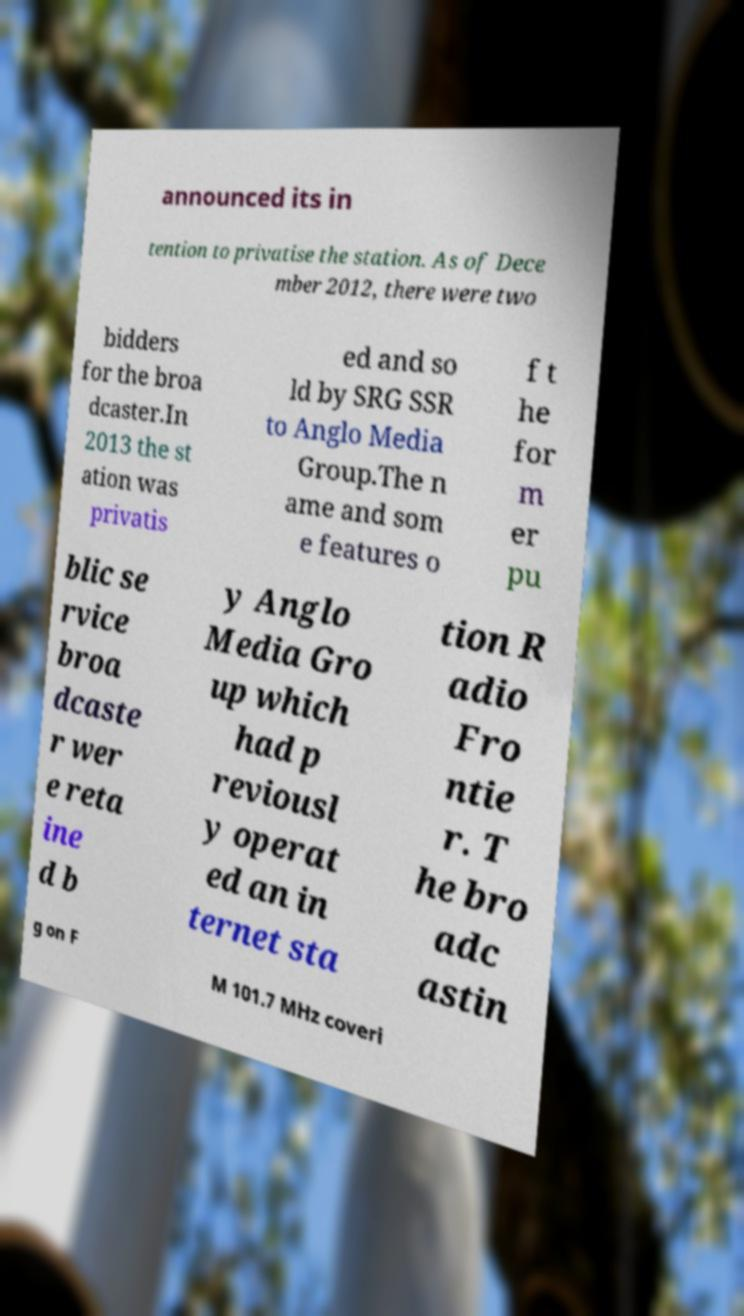Please identify and transcribe the text found in this image. announced its in tention to privatise the station. As of Dece mber 2012, there were two bidders for the broa dcaster.In 2013 the st ation was privatis ed and so ld by SRG SSR to Anglo Media Group.The n ame and som e features o f t he for m er pu blic se rvice broa dcaste r wer e reta ine d b y Anglo Media Gro up which had p reviousl y operat ed an in ternet sta tion R adio Fro ntie r. T he bro adc astin g on F M 101.7 MHz coveri 